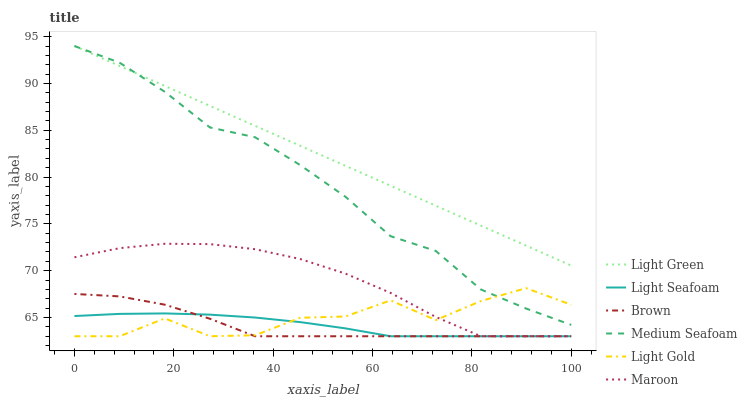Does Brown have the minimum area under the curve?
Answer yes or no. Yes. Does Light Green have the maximum area under the curve?
Answer yes or no. Yes. Does Maroon have the minimum area under the curve?
Answer yes or no. No. Does Maroon have the maximum area under the curve?
Answer yes or no. No. Is Light Green the smoothest?
Answer yes or no. Yes. Is Light Gold the roughest?
Answer yes or no. Yes. Is Maroon the smoothest?
Answer yes or no. No. Is Maroon the roughest?
Answer yes or no. No. Does Brown have the lowest value?
Answer yes or no. Yes. Does Light Green have the lowest value?
Answer yes or no. No. Does Medium Seafoam have the highest value?
Answer yes or no. Yes. Does Maroon have the highest value?
Answer yes or no. No. Is Brown less than Medium Seafoam?
Answer yes or no. Yes. Is Light Green greater than Maroon?
Answer yes or no. Yes. Does Light Seafoam intersect Maroon?
Answer yes or no. Yes. Is Light Seafoam less than Maroon?
Answer yes or no. No. Is Light Seafoam greater than Maroon?
Answer yes or no. No. Does Brown intersect Medium Seafoam?
Answer yes or no. No. 